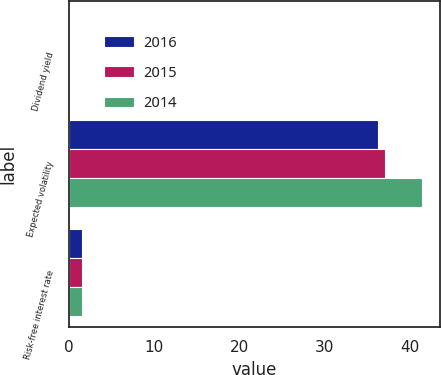Convert chart. <chart><loc_0><loc_0><loc_500><loc_500><stacked_bar_chart><ecel><fcel>Dividend yield<fcel>Expected volatility<fcel>Risk-free interest rate<nl><fcel>2016<fcel>0<fcel>36.2<fcel>1.57<nl><fcel>2015<fcel>0<fcel>37.1<fcel>1.57<nl><fcel>2014<fcel>0<fcel>41.4<fcel>1.55<nl></chart> 